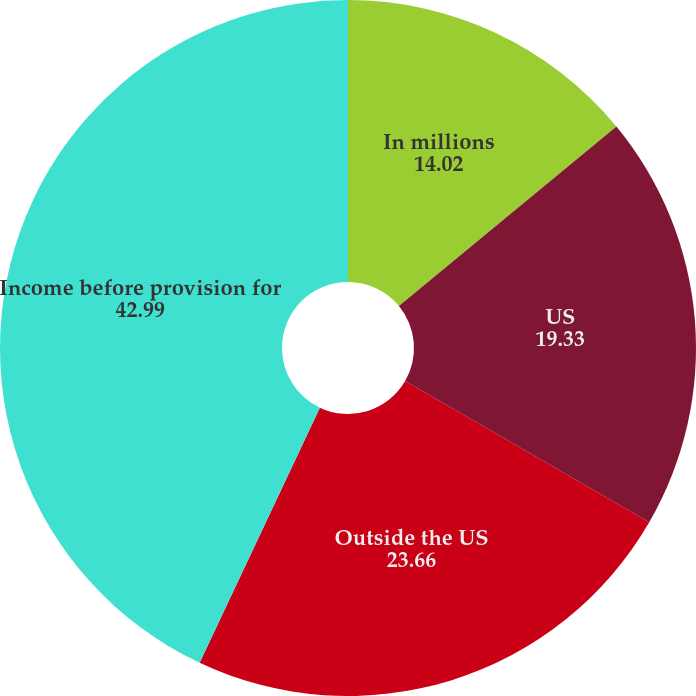<chart> <loc_0><loc_0><loc_500><loc_500><pie_chart><fcel>In millions<fcel>US<fcel>Outside the US<fcel>Income before provision for<nl><fcel>14.02%<fcel>19.33%<fcel>23.66%<fcel>42.99%<nl></chart> 